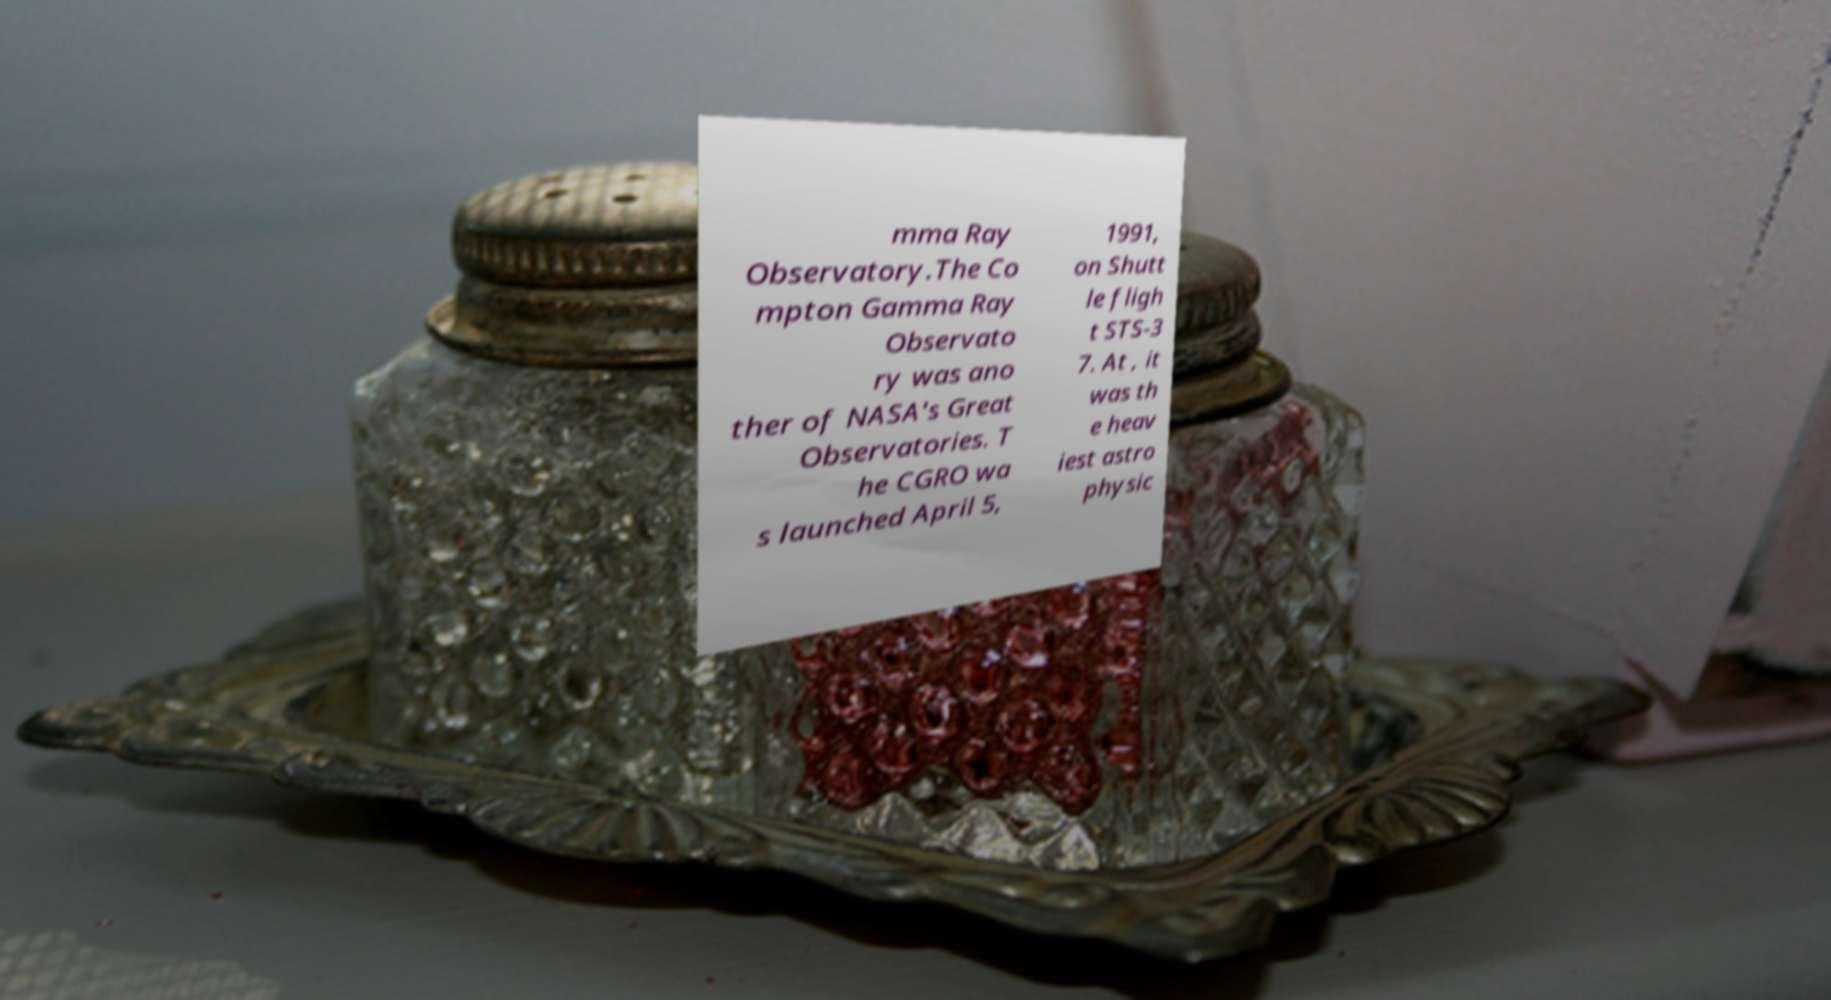Please read and relay the text visible in this image. What does it say? mma Ray Observatory.The Co mpton Gamma Ray Observato ry was ano ther of NASA's Great Observatories. T he CGRO wa s launched April 5, 1991, on Shutt le fligh t STS-3 7. At , it was th e heav iest astro physic 